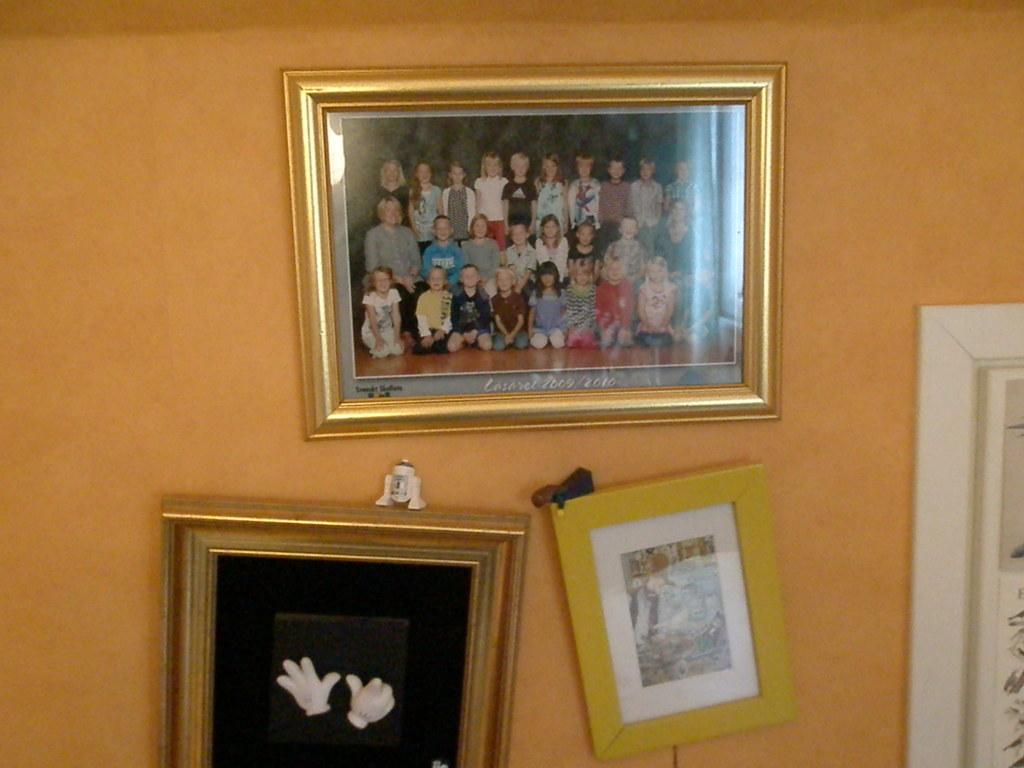<image>
Offer a succinct explanation of the picture presented. a wall with picture frames on it of the lasaret class 